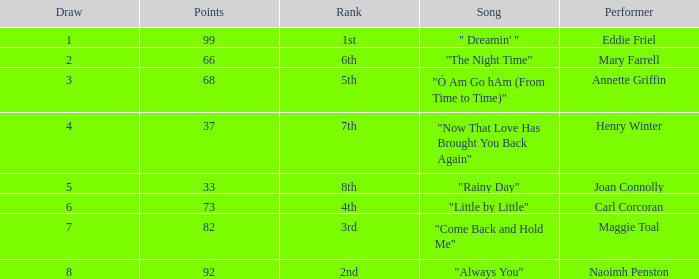What is the lowest points when the ranking is 1st? 99.0. 